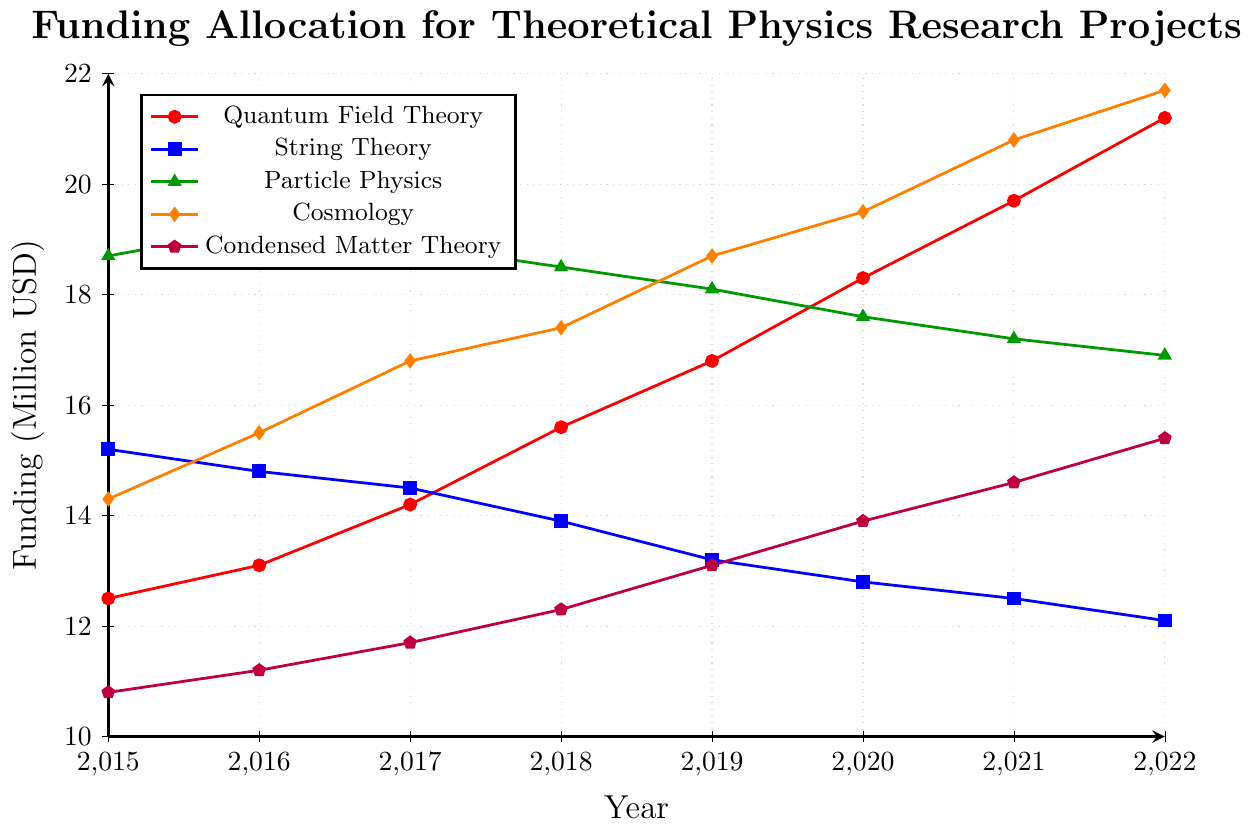What's the average funding for Quantum Field Theory from 2015 to 2022? Sum the funding values for Quantum Field Theory: (12.5 + 13.1 + 14.2 + 15.6 + 16.8 + 18.3 + 19.7 + 21.2) = 131.4. Divide by the number of years, which is 8. So, the average is 131.4 / 8 = 16.425 million USD.
Answer: 16.425 Which area had the highest funding in 2022? In 2022, compare the funding values for all areas: Quantum Field Theory (21.2), String Theory (12.1), Particle Physics (16.9), Cosmology (21.7), and Condensed Matter Theory (15.4). Cosmology has the highest value of 21.7 million USD.
Answer: Cosmology Did String Theory funding increase or decrease from 2015 to 2022? Check the funding for String Theory in 2015 (15.2) and in 2022 (12.1). Since 12.1 is less than 15.2, the funding decreased.
Answer: Decrease Which area had the least variability in funding between 2015 and 2022? Calculate the range (maximum - minimum) for each area: 
- Quantum Field Theory: 21.2 - 12.5 = 8.7
- String Theory: 15.2 - 12.1 = 3.1
- Particle Physics: 19.2 - 16.9 = 2.3
- Cosmology: 21.7 - 14.3 = 7.4
- Condensed Matter Theory: 15.4 - 10.8 = 4.6
Particle Physics has the smallest range of 2.3, indicating the least variability.
Answer: Particle Physics By how much did Cosmology funding change from 2015 to 2022? Calculate the difference in funding for Cosmology between 2015 (14.3 million USD) and 2022 (21.7 million USD). The change is 21.7 - 14.3 = 7.4 million USD.
Answer: 7.4 million USD In what year did Quantum Field Theory surpass 15 million USD in funding? Identify the year when Quantum Field Theory funding exceeded 15 million: In 2018, the funding was 15.6 million USD, which is the first instance of surpassing 15 million.
Answer: 2018 Compare the funding allocation trend of String Theory and Condensed Matter Theory. Which one shows consistent growth? String Theory funding decreases from 15.2 in 2015 to 12.1 in 2022, indicating a decline. Condensed Matter Theory funding increases from 10.8 in 2015 to 15.4 in 2022, showing consistent growth.
Answer: Condensed Matter Theory What is the combined funding for Particle Physics and Cosmology in 2020? Add the funding values for Particle Physics (17.6) and Cosmology (19.5) in 2020. The combined funding is 17.6 + 19.5 = 37.1 million USD.
Answer: 37.1 million USD 